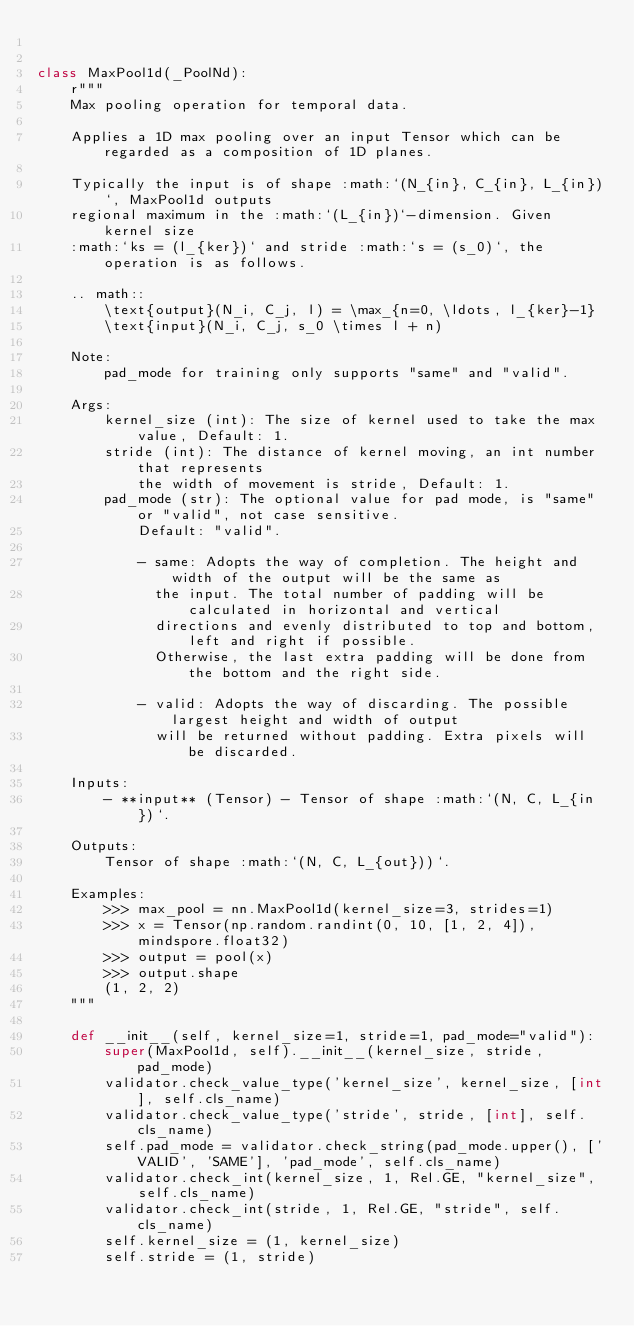<code> <loc_0><loc_0><loc_500><loc_500><_Python_>

class MaxPool1d(_PoolNd):
    r"""
    Max pooling operation for temporal data.

    Applies a 1D max pooling over an input Tensor which can be regarded as a composition of 1D planes.

    Typically the input is of shape :math:`(N_{in}, C_{in}, L_{in})`, MaxPool1d outputs
    regional maximum in the :math:`(L_{in})`-dimension. Given kernel size
    :math:`ks = (l_{ker})` and stride :math:`s = (s_0)`, the operation is as follows.

    .. math::
        \text{output}(N_i, C_j, l) = \max_{n=0, \ldots, l_{ker}-1}
        \text{input}(N_i, C_j, s_0 \times l + n)

    Note:
        pad_mode for training only supports "same" and "valid".

    Args:
        kernel_size (int): The size of kernel used to take the max value, Default: 1.
        stride (int): The distance of kernel moving, an int number that represents
            the width of movement is stride, Default: 1.
        pad_mode (str): The optional value for pad mode, is "same" or "valid", not case sensitive.
            Default: "valid".

            - same: Adopts the way of completion. The height and width of the output will be the same as
              the input. The total number of padding will be calculated in horizontal and vertical
              directions and evenly distributed to top and bottom, left and right if possible.
              Otherwise, the last extra padding will be done from the bottom and the right side.

            - valid: Adopts the way of discarding. The possible largest height and width of output
              will be returned without padding. Extra pixels will be discarded.

    Inputs:
        - **input** (Tensor) - Tensor of shape :math:`(N, C, L_{in})`.

    Outputs:
        Tensor of shape :math:`(N, C, L_{out}))`.

    Examples:
        >>> max_pool = nn.MaxPool1d(kernel_size=3, strides=1)
        >>> x = Tensor(np.random.randint(0, 10, [1, 2, 4]), mindspore.float32)
        >>> output = pool(x)
        >>> output.shape
        (1, 2, 2)
    """

    def __init__(self, kernel_size=1, stride=1, pad_mode="valid"):
        super(MaxPool1d, self).__init__(kernel_size, stride, pad_mode)
        validator.check_value_type('kernel_size', kernel_size, [int], self.cls_name)
        validator.check_value_type('stride', stride, [int], self.cls_name)
        self.pad_mode = validator.check_string(pad_mode.upper(), ['VALID', 'SAME'], 'pad_mode', self.cls_name)
        validator.check_int(kernel_size, 1, Rel.GE, "kernel_size", self.cls_name)
        validator.check_int(stride, 1, Rel.GE, "stride", self.cls_name)
        self.kernel_size = (1, kernel_size)
        self.stride = (1, stride)</code> 